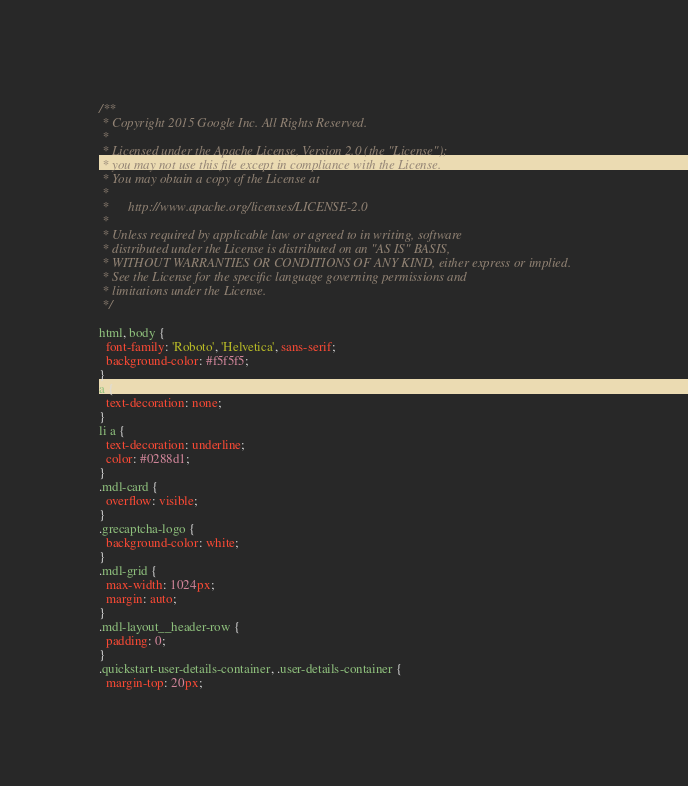<code> <loc_0><loc_0><loc_500><loc_500><_CSS_>/**
 * Copyright 2015 Google Inc. All Rights Reserved.
 *
 * Licensed under the Apache License, Version 2.0 (the "License");
 * you may not use this file except in compliance with the License.
 * You may obtain a copy of the License at
 *
 *      http://www.apache.org/licenses/LICENSE-2.0
 *
 * Unless required by applicable law or agreed to in writing, software
 * distributed under the License is distributed on an "AS IS" BASIS,
 * WITHOUT WARRANTIES OR CONDITIONS OF ANY KIND, either express or implied.
 * See the License for the specific language governing permissions and
 * limitations under the License.
 */

html, body {
  font-family: 'Roboto', 'Helvetica', sans-serif;
  background-color: #f5f5f5;
}
a {
  text-decoration: none;
}
li a {
  text-decoration: underline;
  color: #0288d1;
}
.mdl-card {
  overflow: visible;
}
.grecaptcha-logo {
  background-color: white;
}
.mdl-grid {
  max-width: 1024px;
  margin: auto;
}
.mdl-layout__header-row {
  padding: 0;
}
.quickstart-user-details-container, .user-details-container {
  margin-top: 20px;</code> 